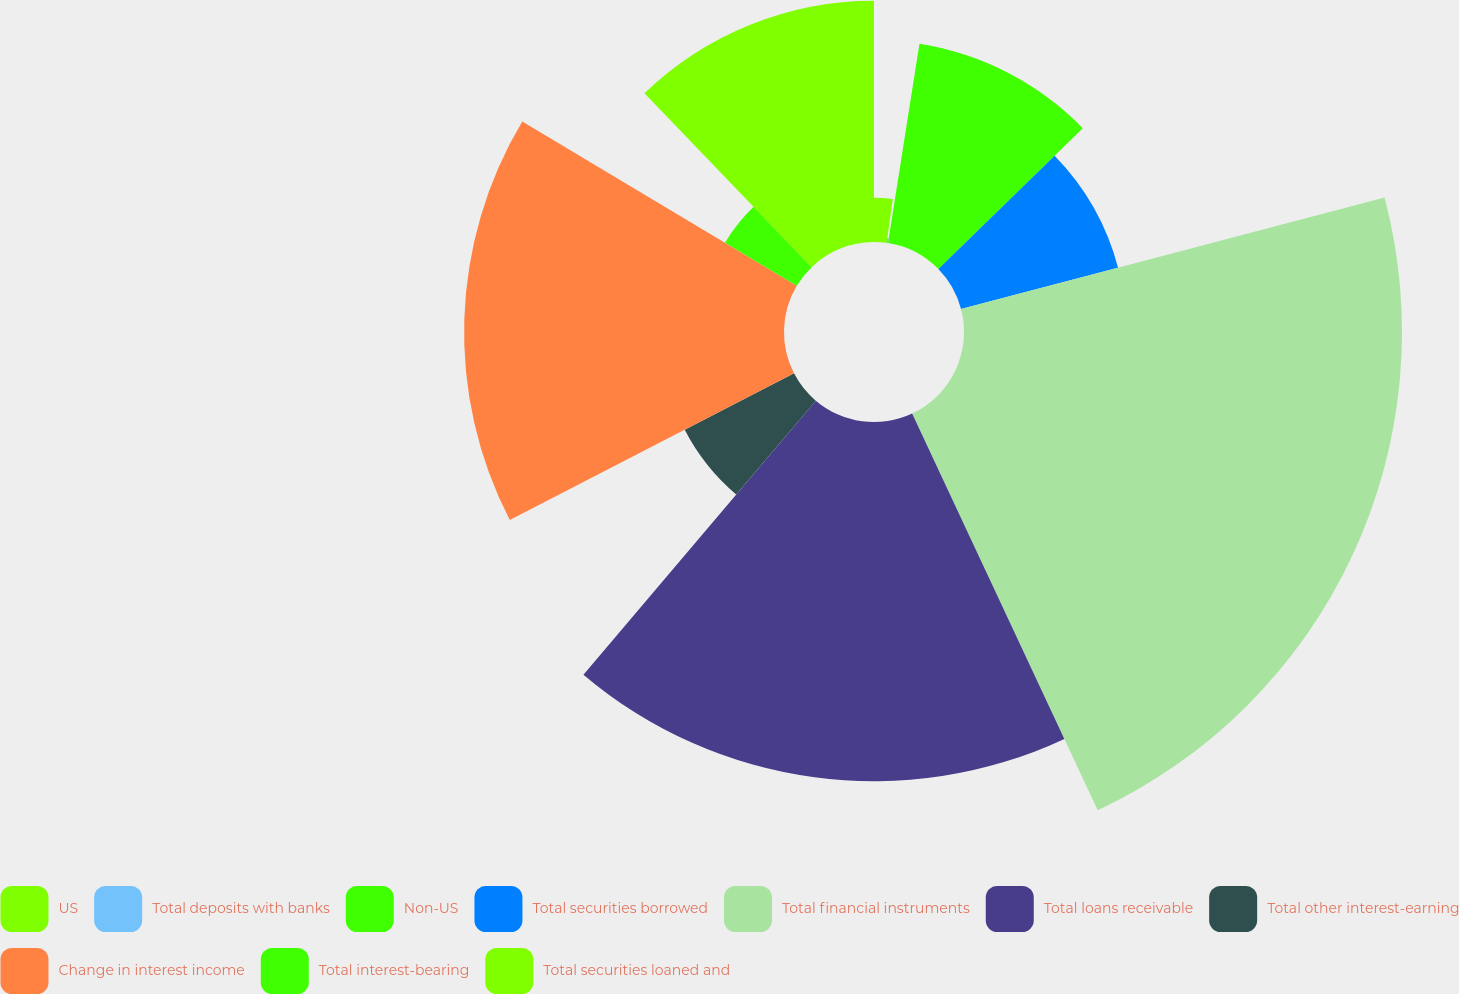Convert chart. <chart><loc_0><loc_0><loc_500><loc_500><pie_chart><fcel>US<fcel>Total deposits with banks<fcel>Non-US<fcel>Total securities borrowed<fcel>Total financial instruments<fcel>Total loans receivable<fcel>Total other interest-earning<fcel>Change in interest income<fcel>Total interest-bearing<fcel>Total securities loaned and<nl><fcel>2.24%<fcel>0.25%<fcel>10.2%<fcel>8.21%<fcel>22.14%<fcel>18.16%<fcel>6.22%<fcel>16.17%<fcel>4.23%<fcel>12.19%<nl></chart> 